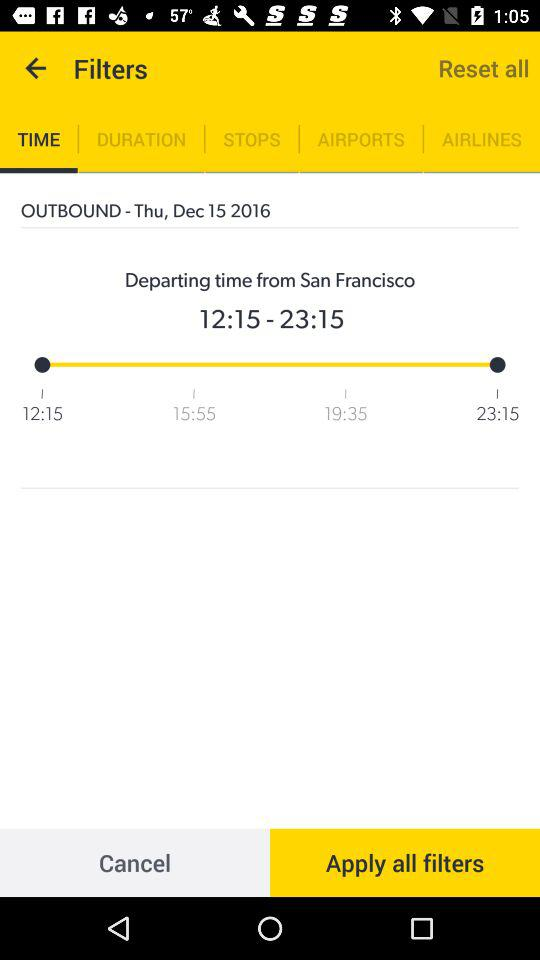When does the flight arrive? The flight will arrive at 23:15. 